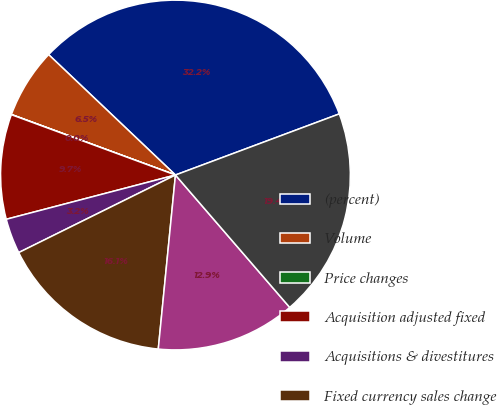Convert chart. <chart><loc_0><loc_0><loc_500><loc_500><pie_chart><fcel>(percent)<fcel>Volume<fcel>Price changes<fcel>Acquisition adjusted fixed<fcel>Acquisitions & divestitures<fcel>Fixed currency sales change<fcel>Foreign currency translation<fcel>Reported GAAP net sales change<nl><fcel>32.23%<fcel>6.46%<fcel>0.02%<fcel>9.68%<fcel>3.24%<fcel>16.12%<fcel>12.9%<fcel>19.35%<nl></chart> 